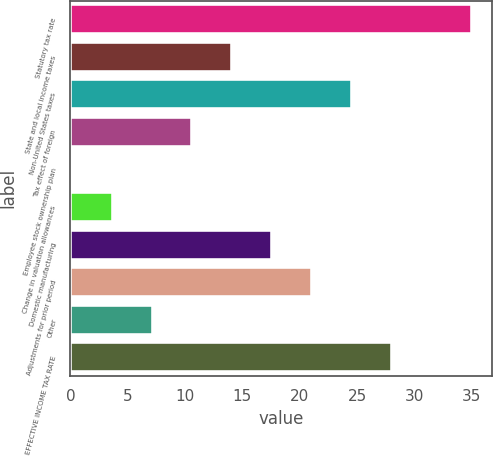<chart> <loc_0><loc_0><loc_500><loc_500><bar_chart><fcel>Statutory tax rate<fcel>State and local income taxes<fcel>Non-United States taxes<fcel>Tax effect of foreign<fcel>Employee stock ownership plan<fcel>Change in valuation allowances<fcel>Domestic manufacturing<fcel>Adjustments for prior period<fcel>Other<fcel>EFFECTIVE INCOME TAX RATE<nl><fcel>35<fcel>14.12<fcel>24.56<fcel>10.64<fcel>0.2<fcel>3.68<fcel>17.6<fcel>21.08<fcel>7.16<fcel>28.04<nl></chart> 